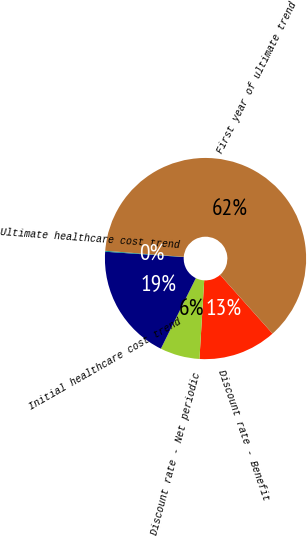<chart> <loc_0><loc_0><loc_500><loc_500><pie_chart><fcel>Discount rate - Benefit<fcel>Discount rate - Net periodic<fcel>Initial healthcare cost trend<fcel>Ultimate healthcare cost trend<fcel>First year of ultimate trend<nl><fcel>12.56%<fcel>6.36%<fcel>18.76%<fcel>0.15%<fcel>62.17%<nl></chart> 